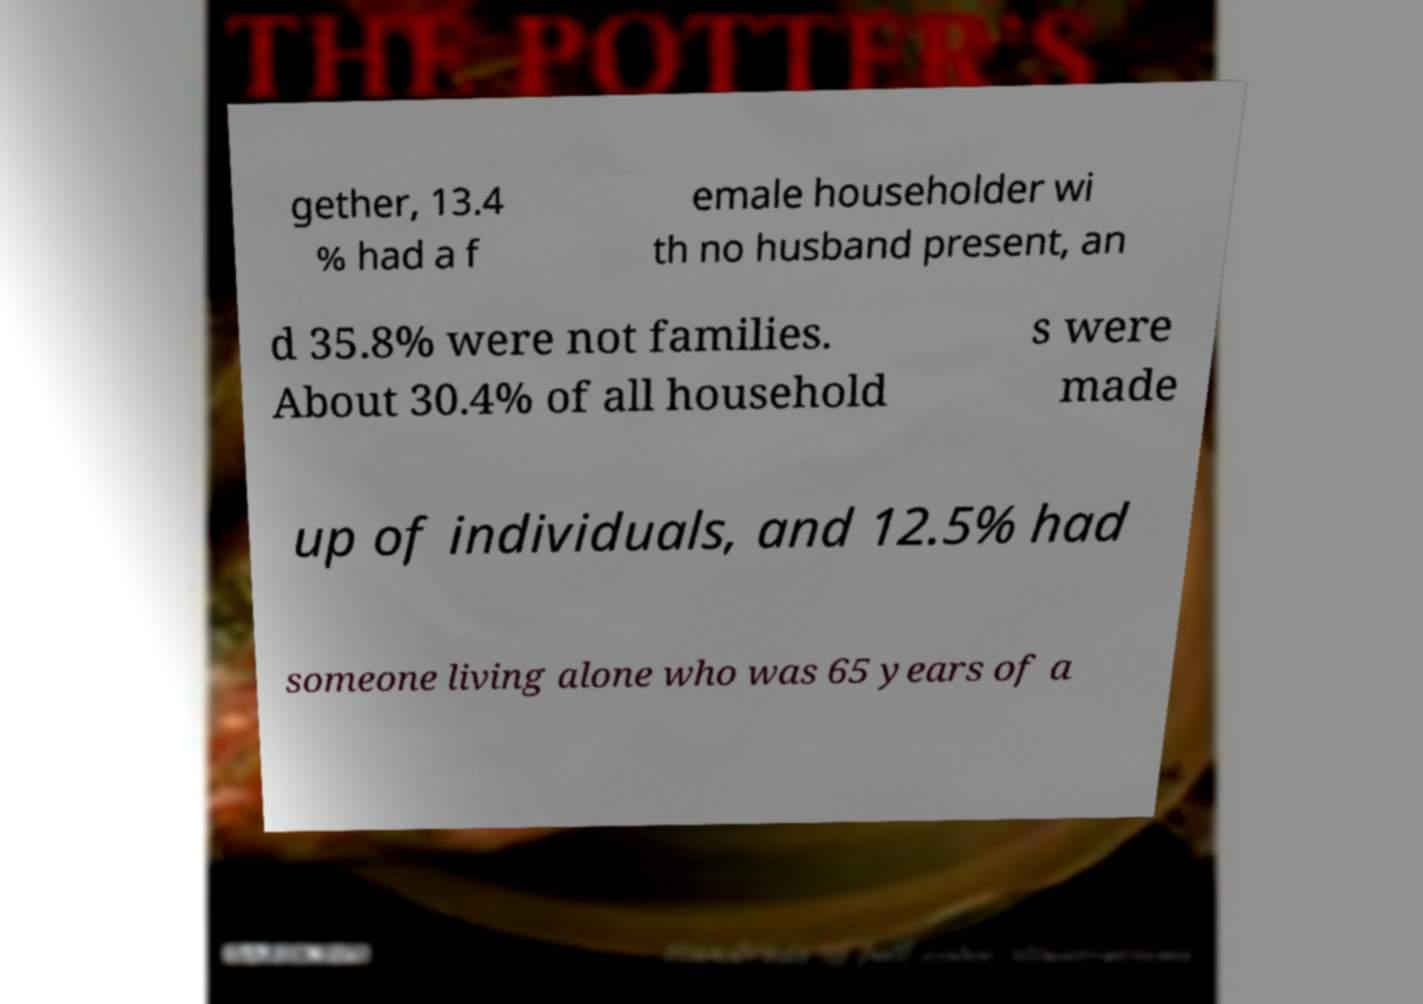Could you assist in decoding the text presented in this image and type it out clearly? gether, 13.4 % had a f emale householder wi th no husband present, an d 35.8% were not families. About 30.4% of all household s were made up of individuals, and 12.5% had someone living alone who was 65 years of a 